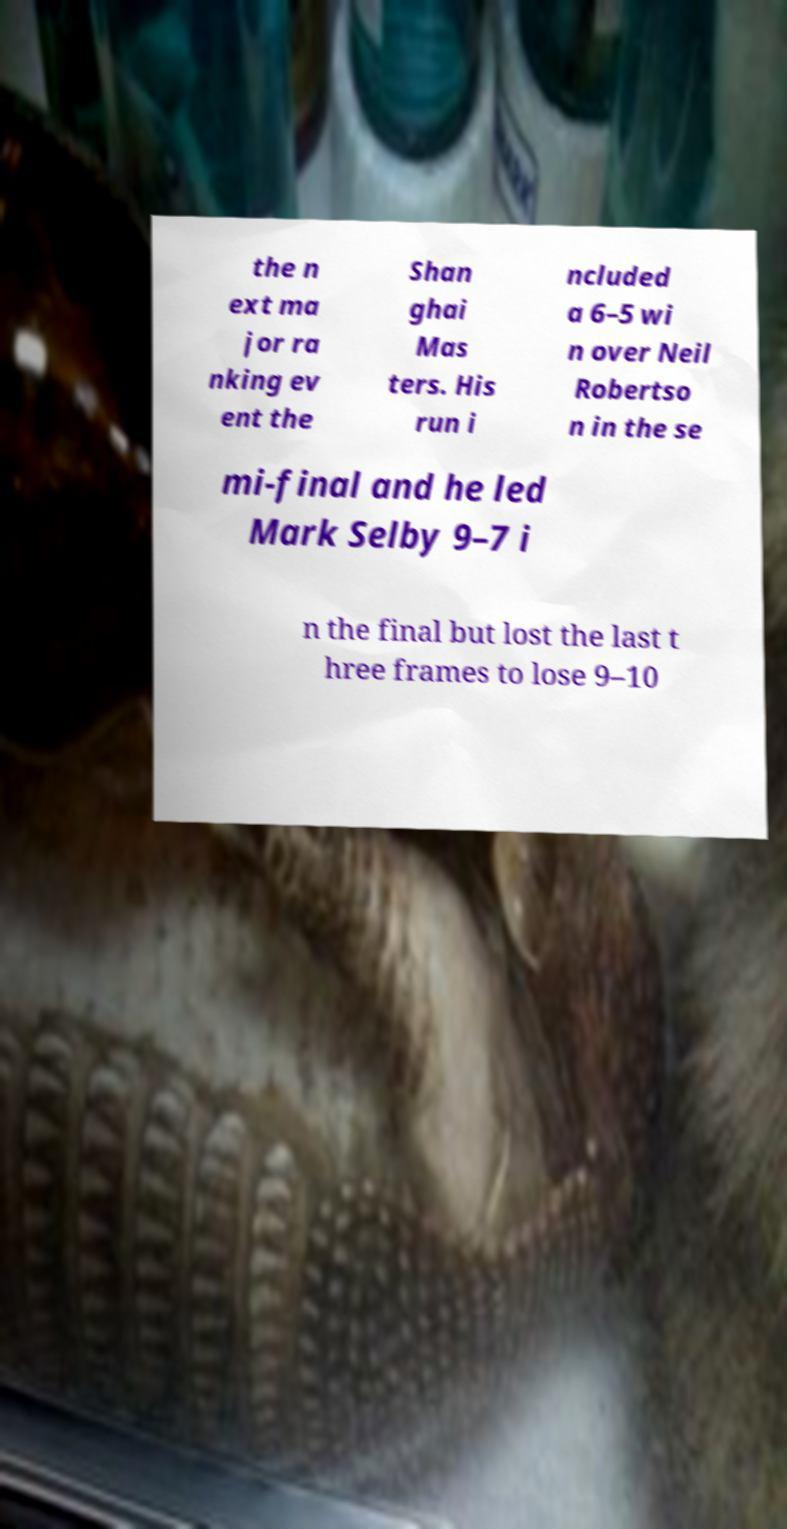What messages or text are displayed in this image? I need them in a readable, typed format. the n ext ma jor ra nking ev ent the Shan ghai Mas ters. His run i ncluded a 6–5 wi n over Neil Robertso n in the se mi-final and he led Mark Selby 9–7 i n the final but lost the last t hree frames to lose 9–10 